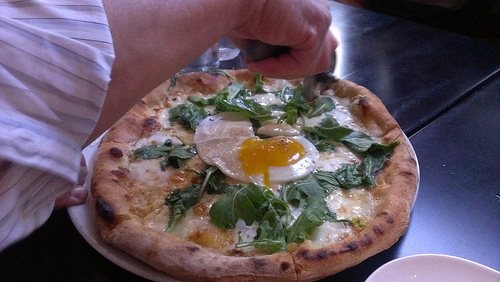Is there any cheese in this image? Yes, there is cheese visible in the image. 